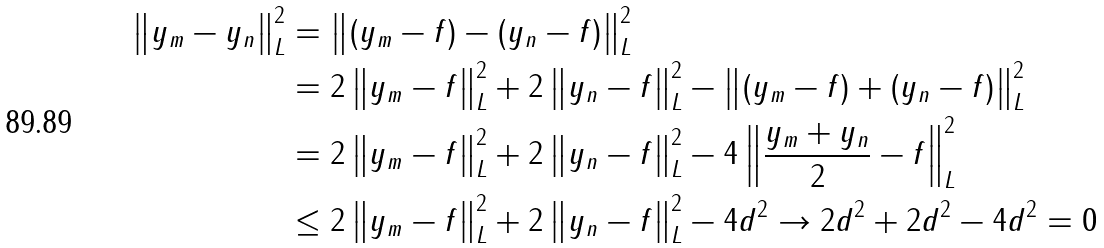Convert formula to latex. <formula><loc_0><loc_0><loc_500><loc_500>\left \| y _ { m } - y _ { n } \right \| _ { L } ^ { 2 } & = \left \| ( y _ { m } - f ) - ( y _ { n } - f ) \right \| _ { L } ^ { 2 } \\ & = 2 \left \| y _ { m } - f \right \| _ { L } ^ { 2 } + 2 \left \| y _ { n } - f \right \| _ { L } ^ { 2 } - \left \| ( y _ { m } - f ) + ( y _ { n } - f ) \right \| _ { L } ^ { 2 } \\ & = 2 \left \| y _ { m } - f \right \| _ { L } ^ { 2 } + 2 \left \| y _ { n } - f \right \| _ { L } ^ { 2 } - 4 \left \| \frac { y _ { m } + y _ { n } } { 2 } - f \right \| _ { L } ^ { 2 } \\ & \leq 2 \left \| y _ { m } - f \right \| _ { L } ^ { 2 } + 2 \left \| y _ { n } - f \right \| _ { L } ^ { 2 } - 4 d ^ { 2 } \to 2 d ^ { 2 } + 2 d ^ { 2 } - 4 d ^ { 2 } = 0</formula> 